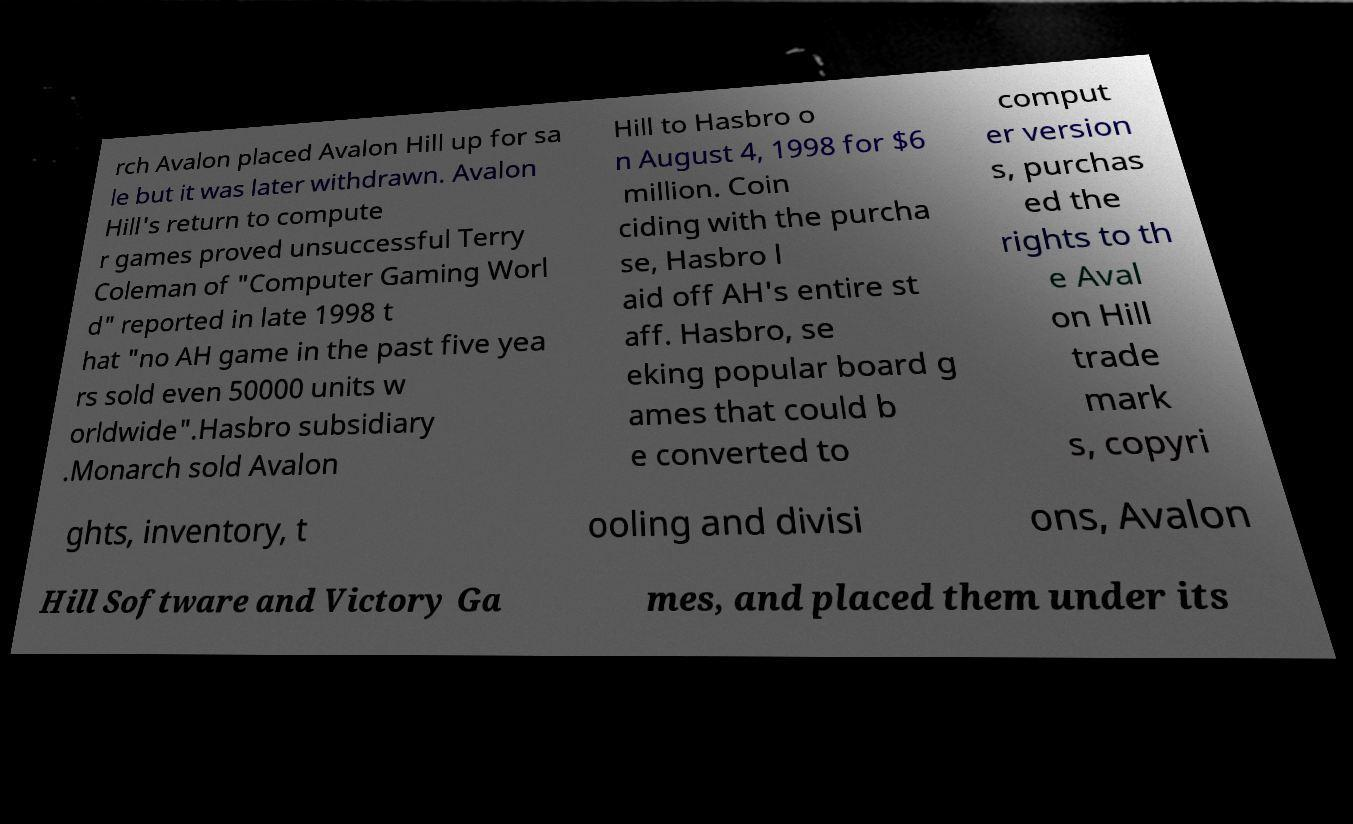Please read and relay the text visible in this image. What does it say? rch Avalon placed Avalon Hill up for sa le but it was later withdrawn. Avalon Hill's return to compute r games proved unsuccessful Terry Coleman of "Computer Gaming Worl d" reported in late 1998 t hat "no AH game in the past five yea rs sold even 50000 units w orldwide".Hasbro subsidiary .Monarch sold Avalon Hill to Hasbro o n August 4, 1998 for $6 million. Coin ciding with the purcha se, Hasbro l aid off AH's entire st aff. Hasbro, se eking popular board g ames that could b e converted to comput er version s, purchas ed the rights to th e Aval on Hill trade mark s, copyri ghts, inventory, t ooling and divisi ons, Avalon Hill Software and Victory Ga mes, and placed them under its 